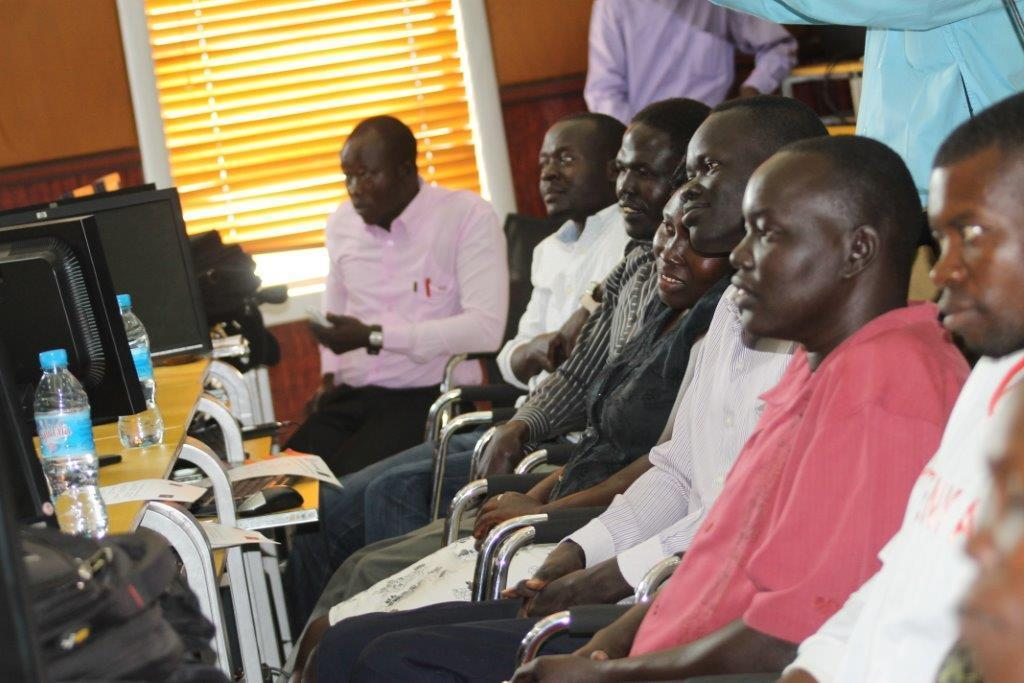What are the people in the image doing? The people in the image are sitting on the right side. What is in front of the people? There is a table in front of the people. What is on the table? There are monitors on the table. What can be seen in the background of the image? There is a wall in the background of the image. What type of whip can be seen in the image? There is no whip present in the image. What angle is the camera positioned at in the image? The angle of the camera cannot be determined from the image itself, as it is a still photograph. 